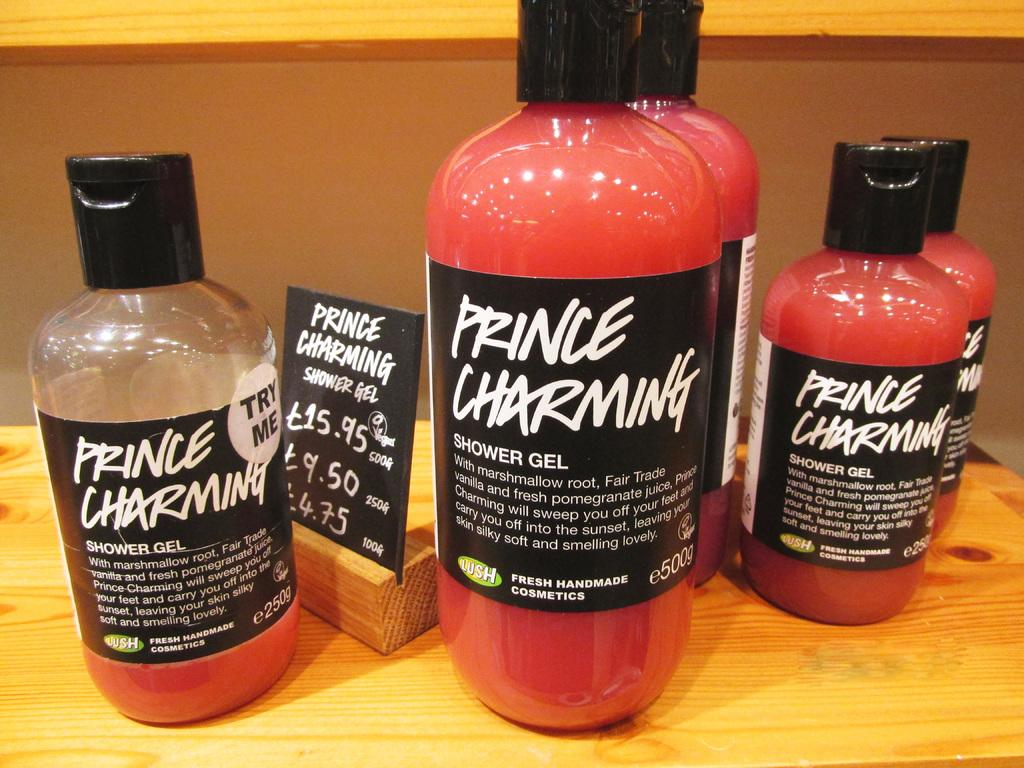<image>
Share a concise interpretation of the image provided. A display of shower gel products is arranged on a table. 